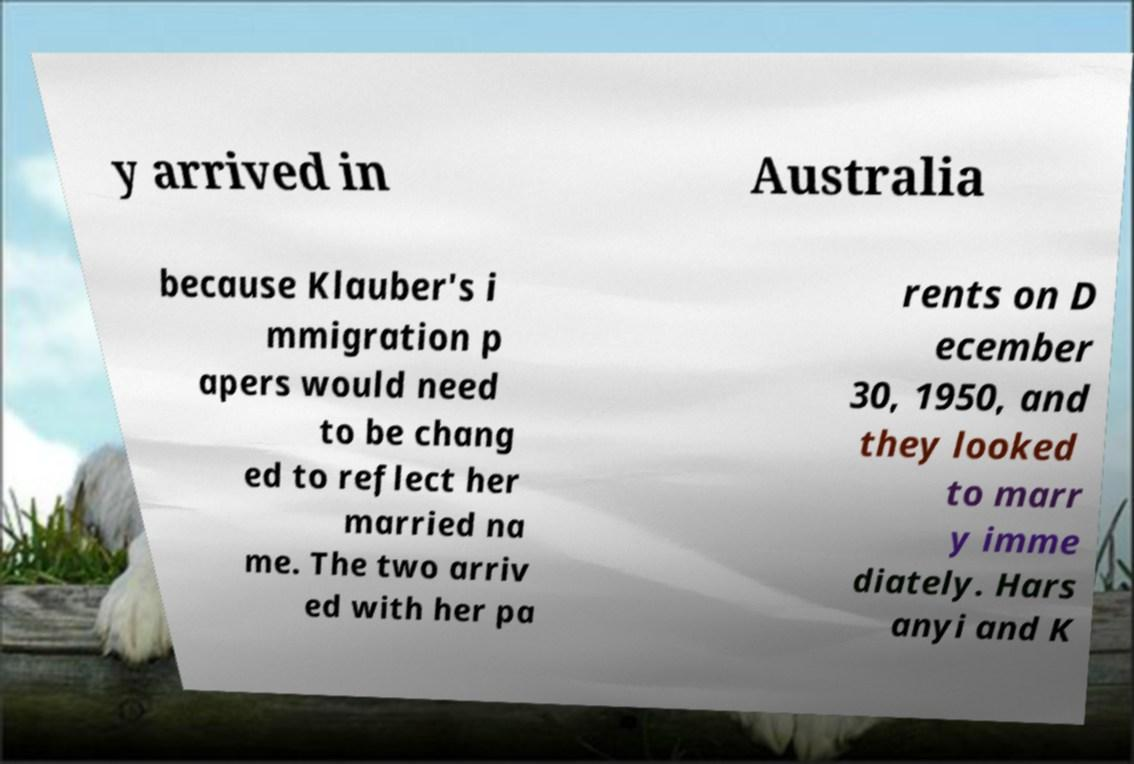Please identify and transcribe the text found in this image. y arrived in Australia because Klauber's i mmigration p apers would need to be chang ed to reflect her married na me. The two arriv ed with her pa rents on D ecember 30, 1950, and they looked to marr y imme diately. Hars anyi and K 